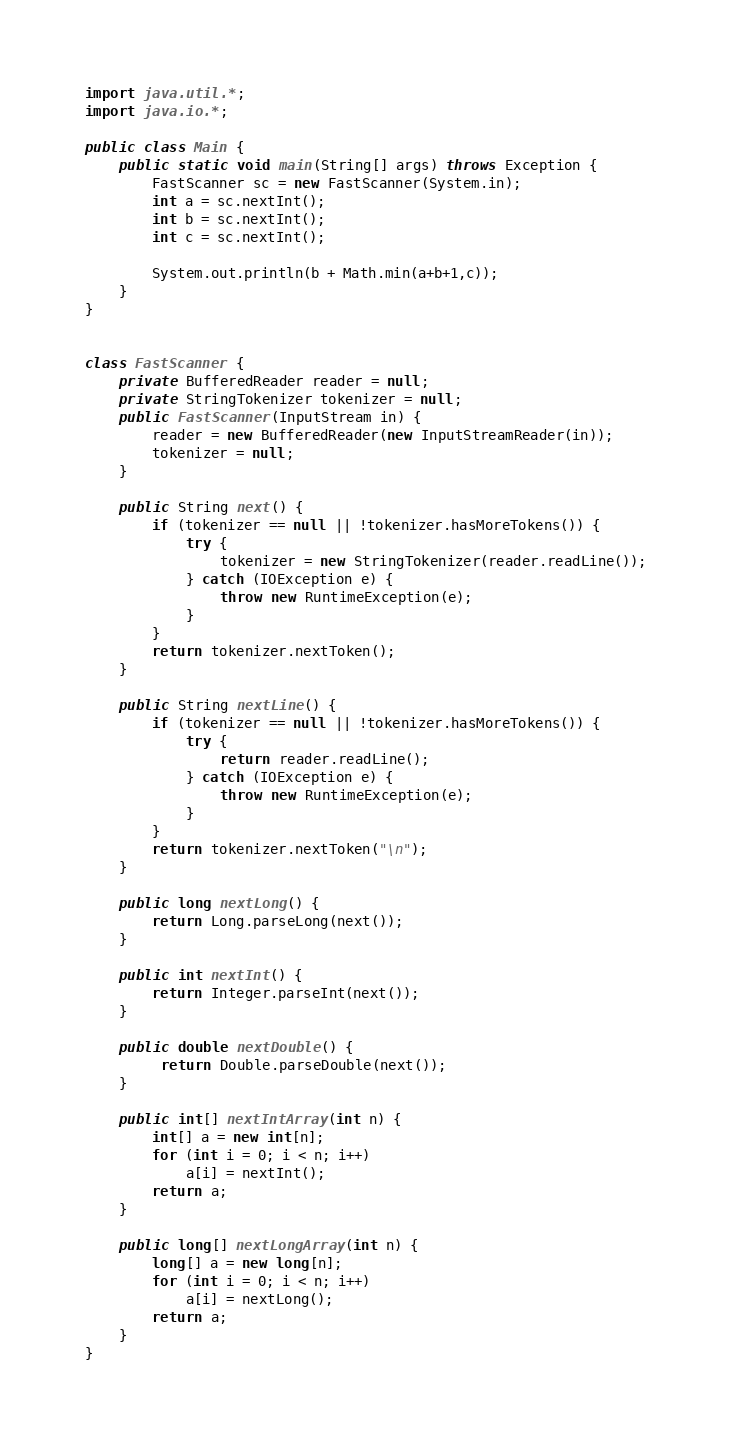<code> <loc_0><loc_0><loc_500><loc_500><_Java_>import java.util.*;
import java.io.*;
 
public class Main {
    public static void main(String[] args) throws Exception {
        FastScanner sc = new FastScanner(System.in);
        int a = sc.nextInt();
        int b = sc.nextInt();
        int c = sc.nextInt();
        
        System.out.println(b + Math.min(a+b+1,c));
    }
}


class FastScanner {
    private BufferedReader reader = null;
    private StringTokenizer tokenizer = null;
    public FastScanner(InputStream in) {
        reader = new BufferedReader(new InputStreamReader(in));
        tokenizer = null;
    }

    public String next() {
        if (tokenizer == null || !tokenizer.hasMoreTokens()) {
            try {
                tokenizer = new StringTokenizer(reader.readLine());
            } catch (IOException e) {
                throw new RuntimeException(e);
            }
        }
        return tokenizer.nextToken();
    }

    public String nextLine() {
        if (tokenizer == null || !tokenizer.hasMoreTokens()) {
            try {
                return reader.readLine();
            } catch (IOException e) {
                throw new RuntimeException(e);
            }
        }
        return tokenizer.nextToken("\n");
    }

    public long nextLong() {
        return Long.parseLong(next());
    }

    public int nextInt() {
        return Integer.parseInt(next());
    }

    public double nextDouble() {
         return Double.parseDouble(next());
    }

    public int[] nextIntArray(int n) {
        int[] a = new int[n];
        for (int i = 0; i < n; i++)
            a[i] = nextInt();
        return a;
    }

    public long[] nextLongArray(int n) {
        long[] a = new long[n];
        for (int i = 0; i < n; i++)
            a[i] = nextLong();
        return a;
    } 
}
</code> 